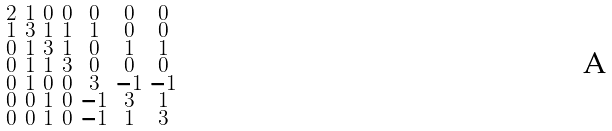Convert formula to latex. <formula><loc_0><loc_0><loc_500><loc_500>\begin{smallmatrix} 2 & 1 & 0 & 0 & 0 & 0 & 0 \\ 1 & 3 & 1 & 1 & 1 & 0 & 0 \\ 0 & 1 & 3 & 1 & 0 & 1 & 1 \\ 0 & 1 & 1 & 3 & 0 & 0 & 0 \\ 0 & 1 & 0 & 0 & 3 & - 1 & - 1 \\ 0 & 0 & 1 & 0 & - 1 & 3 & 1 \\ 0 & 0 & 1 & 0 & - 1 & 1 & 3 \end{smallmatrix}</formula> 